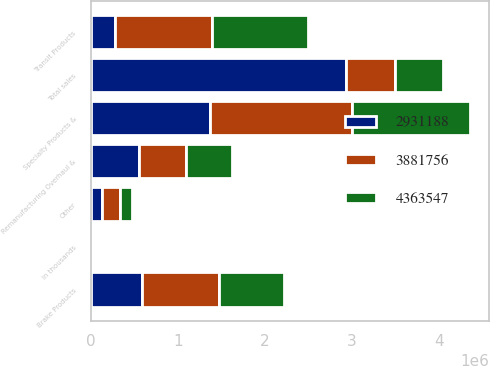Convert chart. <chart><loc_0><loc_0><loc_500><loc_500><stacked_bar_chart><ecel><fcel>In thousands<fcel>Specialty Products &<fcel>Brake Products<fcel>Remanufacturing Overhaul &<fcel>Transit Products<fcel>Other<fcel>Total sales<nl><fcel>3.88176e+06<fcel>2018<fcel>1.63197e+06<fcel>885464<fcel>537122<fcel>1.11155e+06<fcel>197446<fcel>559284<nl><fcel>4.36355e+06<fcel>2017<fcel>1.35073e+06<fcel>749959<fcel>522275<fcel>1.11234e+06<fcel>146455<fcel>559284<nl><fcel>2.93119e+06<fcel>2016<fcel>1.37458e+06<fcel>588081<fcel>559284<fcel>276124<fcel>133119<fcel>2.93119e+06<nl></chart> 